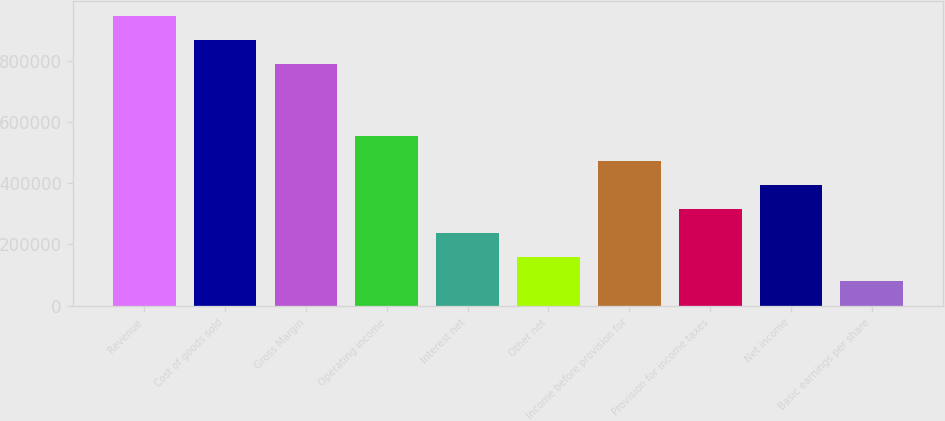Convert chart. <chart><loc_0><loc_0><loc_500><loc_500><bar_chart><fcel>Revenue<fcel>Cost of goods sold<fcel>Gross Margin<fcel>Operating income<fcel>Interest net<fcel>Other net<fcel>Income before provision for<fcel>Provision for income taxes<fcel>Net income<fcel>Basic earnings per share<nl><fcel>947257<fcel>868319<fcel>789381<fcel>552567<fcel>236815<fcel>157877<fcel>473629<fcel>315753<fcel>394691<fcel>78938.5<nl></chart> 